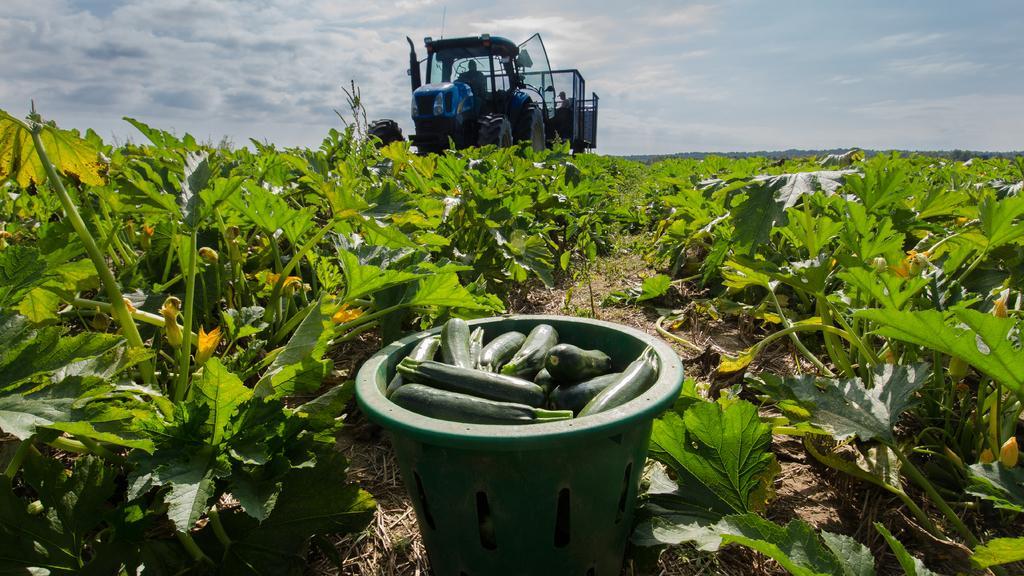In one or two sentences, can you explain what this image depicts? In this picture we can see there are two people sitting in a vehicle and in front of the vehicle there are plants and some vegetables in an object. Behind the vehicle where is the sky. 